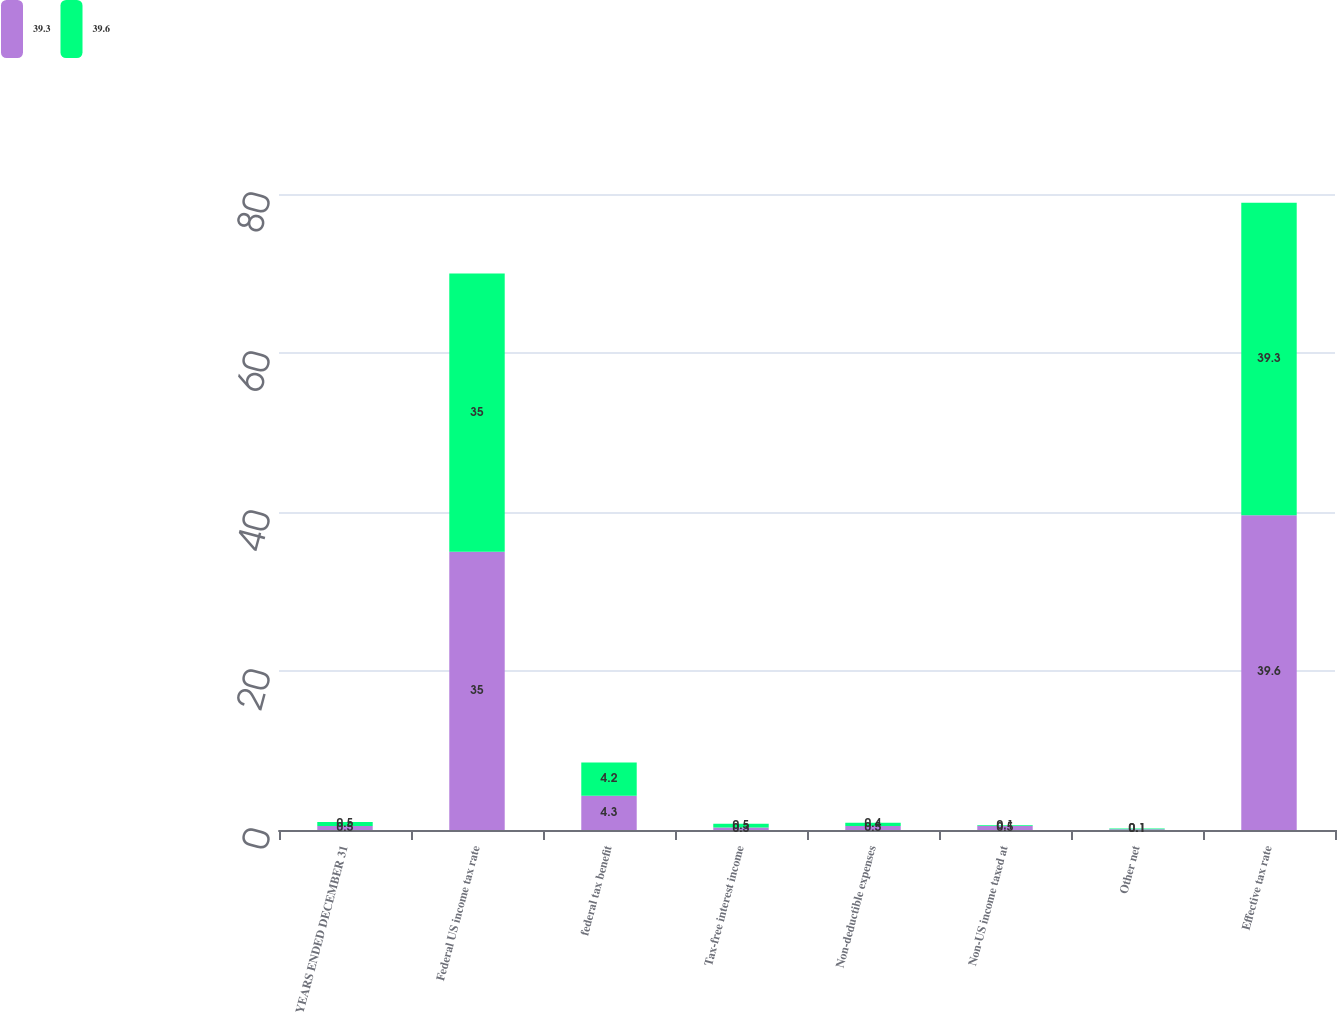<chart> <loc_0><loc_0><loc_500><loc_500><stacked_bar_chart><ecel><fcel>YEARS ENDED DECEMBER 31<fcel>Federal US income tax rate<fcel>federal tax benefit<fcel>Tax-free interest income<fcel>Non-deductible expenses<fcel>Non-US income taxed at<fcel>Other net<fcel>Effective tax rate<nl><fcel>39.3<fcel>0.5<fcel>35<fcel>4.3<fcel>0.3<fcel>0.5<fcel>0.5<fcel>0.1<fcel>39.6<nl><fcel>39.6<fcel>0.5<fcel>35<fcel>4.2<fcel>0.5<fcel>0.4<fcel>0.1<fcel>0.1<fcel>39.3<nl></chart> 